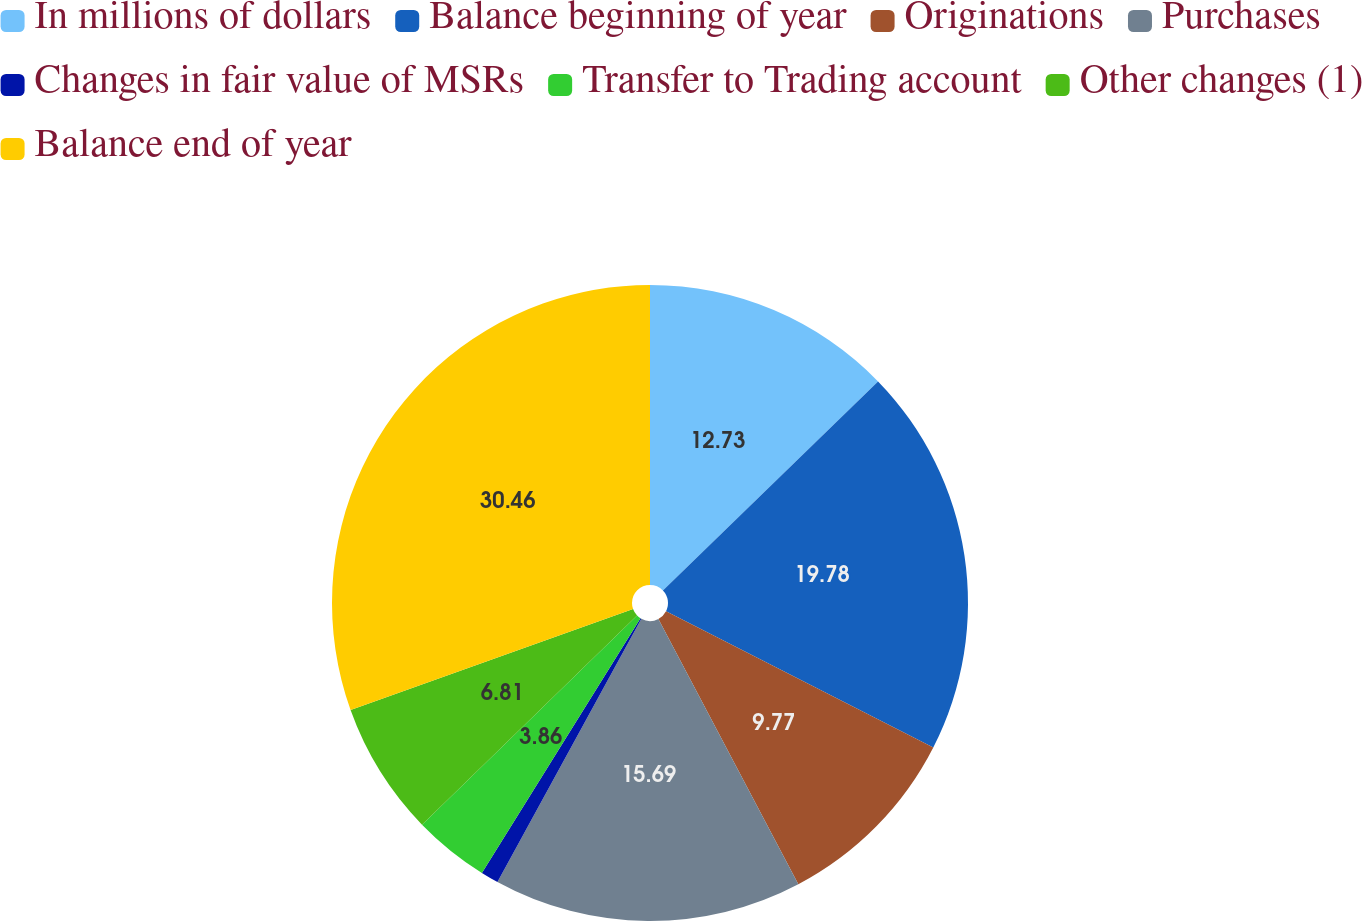Convert chart. <chart><loc_0><loc_0><loc_500><loc_500><pie_chart><fcel>In millions of dollars<fcel>Balance beginning of year<fcel>Originations<fcel>Purchases<fcel>Changes in fair value of MSRs<fcel>Transfer to Trading account<fcel>Other changes (1)<fcel>Balance end of year<nl><fcel>12.73%<fcel>19.78%<fcel>9.77%<fcel>15.69%<fcel>0.9%<fcel>3.86%<fcel>6.81%<fcel>30.47%<nl></chart> 